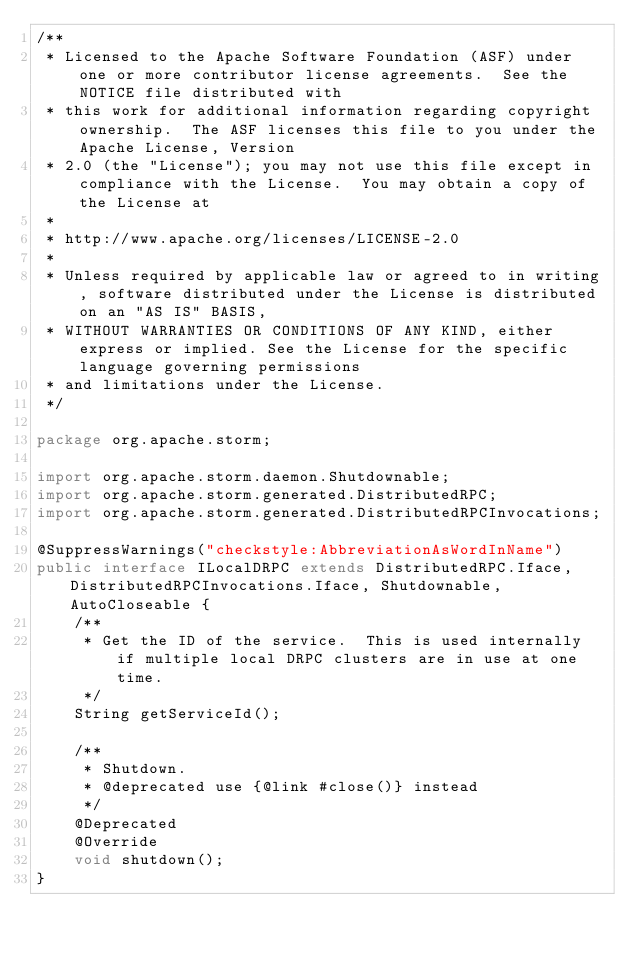Convert code to text. <code><loc_0><loc_0><loc_500><loc_500><_Java_>/**
 * Licensed to the Apache Software Foundation (ASF) under one or more contributor license agreements.  See the NOTICE file distributed with
 * this work for additional information regarding copyright ownership.  The ASF licenses this file to you under the Apache License, Version
 * 2.0 (the "License"); you may not use this file except in compliance with the License.  You may obtain a copy of the License at
 *
 * http://www.apache.org/licenses/LICENSE-2.0
 *
 * Unless required by applicable law or agreed to in writing, software distributed under the License is distributed on an "AS IS" BASIS,
 * WITHOUT WARRANTIES OR CONDITIONS OF ANY KIND, either express or implied. See the License for the specific language governing permissions
 * and limitations under the License.
 */

package org.apache.storm;

import org.apache.storm.daemon.Shutdownable;
import org.apache.storm.generated.DistributedRPC;
import org.apache.storm.generated.DistributedRPCInvocations;

@SuppressWarnings("checkstyle:AbbreviationAsWordInName")
public interface ILocalDRPC extends DistributedRPC.Iface, DistributedRPCInvocations.Iface, Shutdownable, AutoCloseable {
    /**
     * Get the ID of the service.  This is used internally if multiple local DRPC clusters are in use at one time.
     */
    String getServiceId();

    /**
     * Shutdown.
     * @deprecated use {@link #close()} instead
     */
    @Deprecated
    @Override
    void shutdown();
}
</code> 